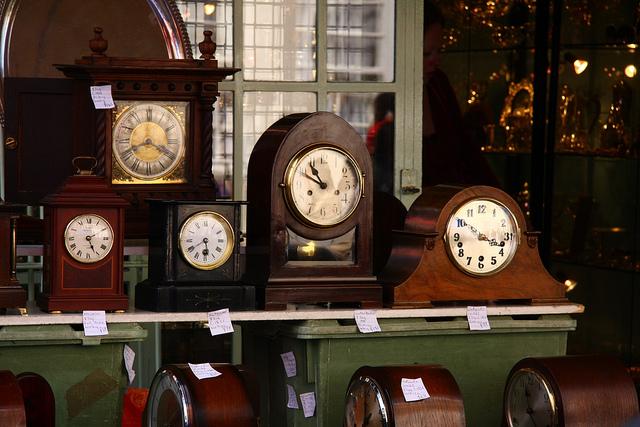How many clock faces can be seen?
Be succinct. 5. Is this someone's home?
Write a very short answer. No. Are the clocks on the same time?
Quick response, please. No. 